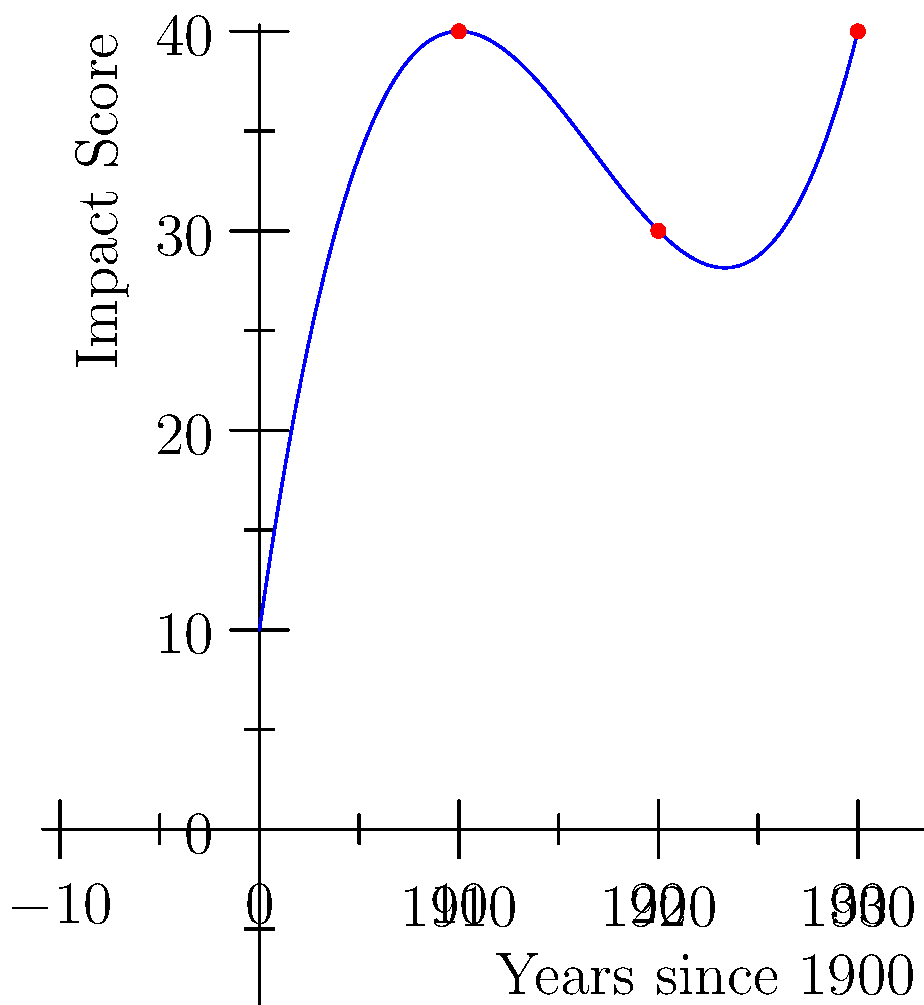Given the polynomial regression model for the impact of scientific discoveries over time, as shown in the graph, how does this model challenge or support the notion of continuous scientific progress? Consider the implications for the years 1910, 1920, and 1930. To analyze this question, let's follow these steps:

1) Observe the graph: The curve represents a polynomial regression model of scientific impact over time, from 1900 to 1930.

2) Identify the polynomial: The shape suggests a cubic polynomial, likely of the form $f(x) = ax^3 + bx^2 + cx + d$, where $x$ represents years since 1900.

3) Analyze the trend:
   - From 1900 to about 1910, there's a steep increase in impact.
   - From 1910 to about 1920, the rate of increase slows down.
   - After 1920, the impact starts to increase more rapidly again.

4) Interpret the implications:
   - 1910: High impact, possibly representing a period of significant discoveries.
   - 1920: Lower rate of increase, suggesting a potential plateau or consolidation phase.
   - 1930: Renewed acceleration, indicating another phase of increased impact.

5) Challenge to continuous progress:
   The non-linear nature of the curve challenges the idea of steady, continuous progress. Instead, it suggests periods of rapid advancement followed by slower growth.

6) Support for nuanced interpretation:
   This model supports a more complex view of scientific progress, showing that:
   - Progress is not always linear or continuous.
   - There are periods of acceleration and deceleration in scientific impact.
   - The cumulative impact of science can still increase even during slower periods.

7) Philosophical implications:
   - This model suggests that scientific progress might be better understood as a series of "punctuated equilibria" rather than a smooth, continuous process.
   - It highlights the need for historians and philosophers of science to consider the contextual factors that might influence these fluctuations in impact.
Answer: The model supports a nuanced view of scientific progress, showing non-linear advancement with periods of acceleration and deceleration, challenging the notion of continuous, steady progress. 